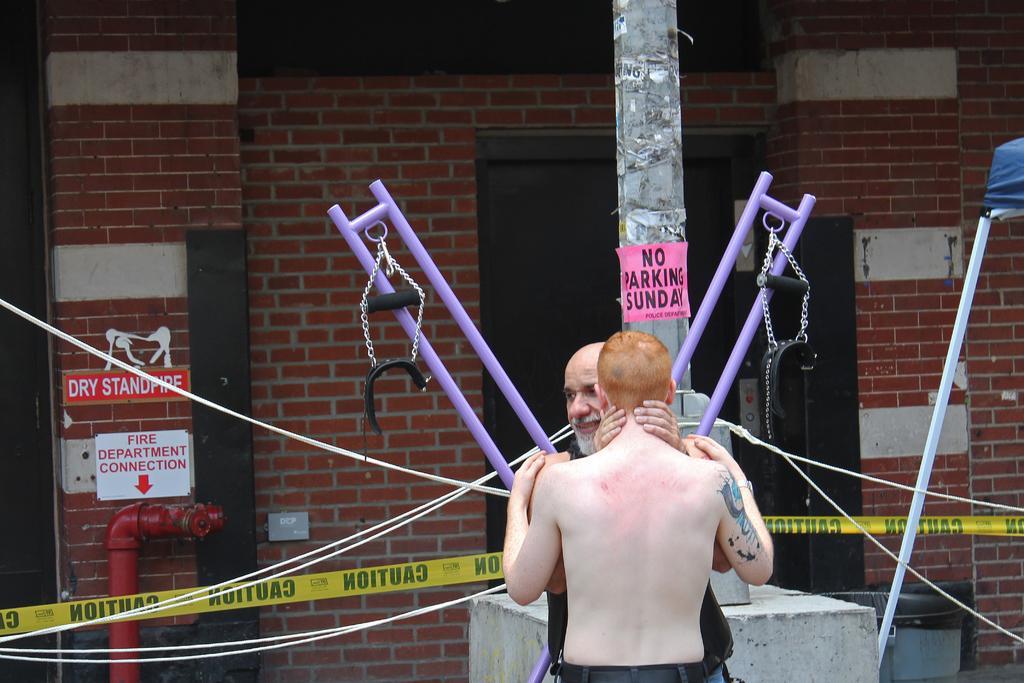Describe this image in one or two sentences. In this picture we can see 2 people holding each other. One person is shirtless with blonde hair and the other person is an old man wearing a black vest. The old man is carrying a purple colored rod with extended wires. Behind these 2 people there is a pole with a NO PARKING SUNDAY sticker attached to it. Behind the pole there is a brick wall with a brown door and there is a pipe attached to the brick wall with fire department connection written on it. 